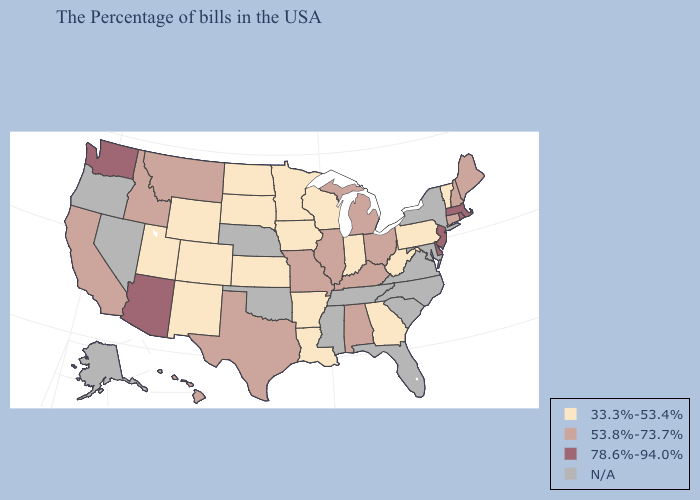What is the value of Texas?
Be succinct. 53.8%-73.7%. Among the states that border Oklahoma , which have the lowest value?
Concise answer only. Arkansas, Kansas, Colorado, New Mexico. Does Minnesota have the lowest value in the USA?
Quick response, please. Yes. Name the states that have a value in the range N/A?
Keep it brief. New York, Maryland, Virginia, North Carolina, South Carolina, Florida, Tennessee, Mississippi, Nebraska, Oklahoma, Nevada, Oregon, Alaska. What is the value of Texas?
Answer briefly. 53.8%-73.7%. Which states have the lowest value in the USA?
Give a very brief answer. Vermont, Pennsylvania, West Virginia, Georgia, Indiana, Wisconsin, Louisiana, Arkansas, Minnesota, Iowa, Kansas, South Dakota, North Dakota, Wyoming, Colorado, New Mexico, Utah. What is the value of Alabama?
Give a very brief answer. 53.8%-73.7%. Which states have the highest value in the USA?
Concise answer only. Massachusetts, Rhode Island, New Jersey, Delaware, Arizona, Washington. What is the value of Michigan?
Answer briefly. 53.8%-73.7%. Name the states that have a value in the range 78.6%-94.0%?
Give a very brief answer. Massachusetts, Rhode Island, New Jersey, Delaware, Arizona, Washington. Which states hav the highest value in the Northeast?
Quick response, please. Massachusetts, Rhode Island, New Jersey. What is the value of South Dakota?
Keep it brief. 33.3%-53.4%. What is the value of Iowa?
Give a very brief answer. 33.3%-53.4%. Name the states that have a value in the range 33.3%-53.4%?
Short answer required. Vermont, Pennsylvania, West Virginia, Georgia, Indiana, Wisconsin, Louisiana, Arkansas, Minnesota, Iowa, Kansas, South Dakota, North Dakota, Wyoming, Colorado, New Mexico, Utah. 